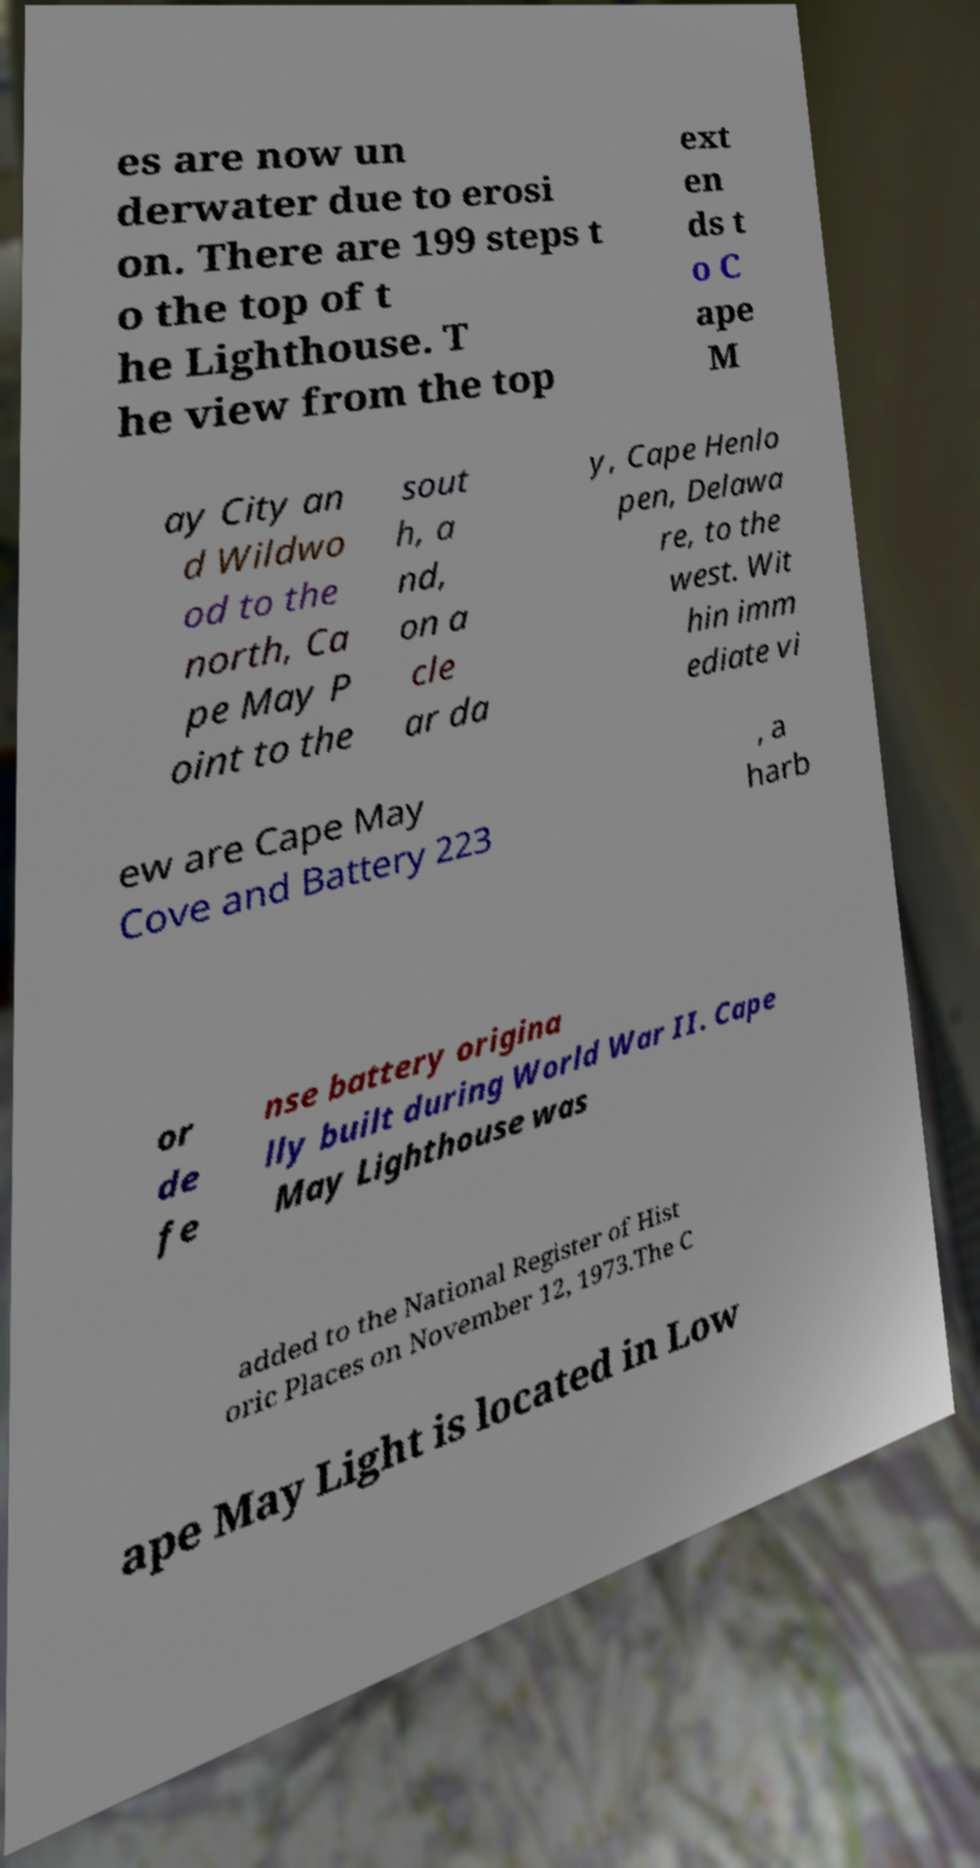Please identify and transcribe the text found in this image. es are now un derwater due to erosi on. There are 199 steps t o the top of t he Lighthouse. T he view from the top ext en ds t o C ape M ay City an d Wildwo od to the north, Ca pe May P oint to the sout h, a nd, on a cle ar da y, Cape Henlo pen, Delawa re, to the west. Wit hin imm ediate vi ew are Cape May Cove and Battery 223 , a harb or de fe nse battery origina lly built during World War II. Cape May Lighthouse was added to the National Register of Hist oric Places on November 12, 1973.The C ape May Light is located in Low 